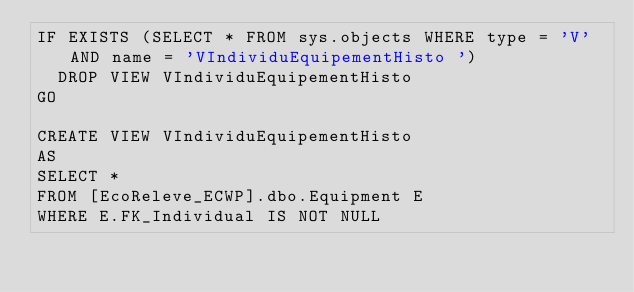<code> <loc_0><loc_0><loc_500><loc_500><_SQL_>IF EXISTS (SELECT * FROM sys.objects WHERE type = 'V' AND name = 'VIndividuEquipementHisto ')
	DROP VIEW VIndividuEquipementHisto
GO

CREATE VIEW VIndividuEquipementHisto
AS
SELECT *
FROM [EcoReleve_ECWP].dbo.Equipment E
WHERE E.FK_Individual IS NOT NULL

</code> 